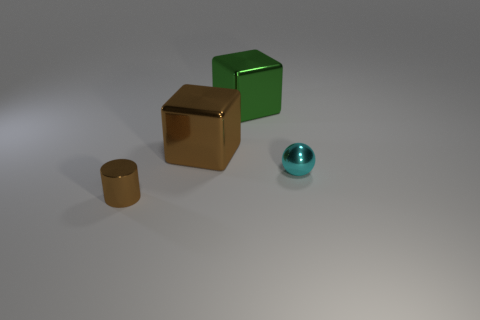There is a object that is to the left of the large brown metallic cube; is its color the same as the metal block that is in front of the green metal thing?
Your response must be concise. Yes. What number of other objects are the same color as the metal cylinder?
Keep it short and to the point. 1. Are there fewer brown cylinders than large blue blocks?
Your response must be concise. No. Are the brown thing behind the brown cylinder and the large green block made of the same material?
Your answer should be compact. Yes. Are there any other things that are the same size as the shiny cylinder?
Make the answer very short. Yes. Are there any green blocks on the left side of the tiny cyan thing?
Your answer should be compact. Yes. What color is the large thing to the left of the large cube that is on the right side of the brown metal object behind the tiny brown metal cylinder?
Provide a succinct answer. Brown. There is a green metallic thing that is the same size as the brown metal cube; what is its shape?
Ensure brevity in your answer.  Cube. Are there more small cylinders than blue metal things?
Your response must be concise. Yes. There is a large block in front of the large green metal thing; is there a cyan ball behind it?
Offer a very short reply. No. 